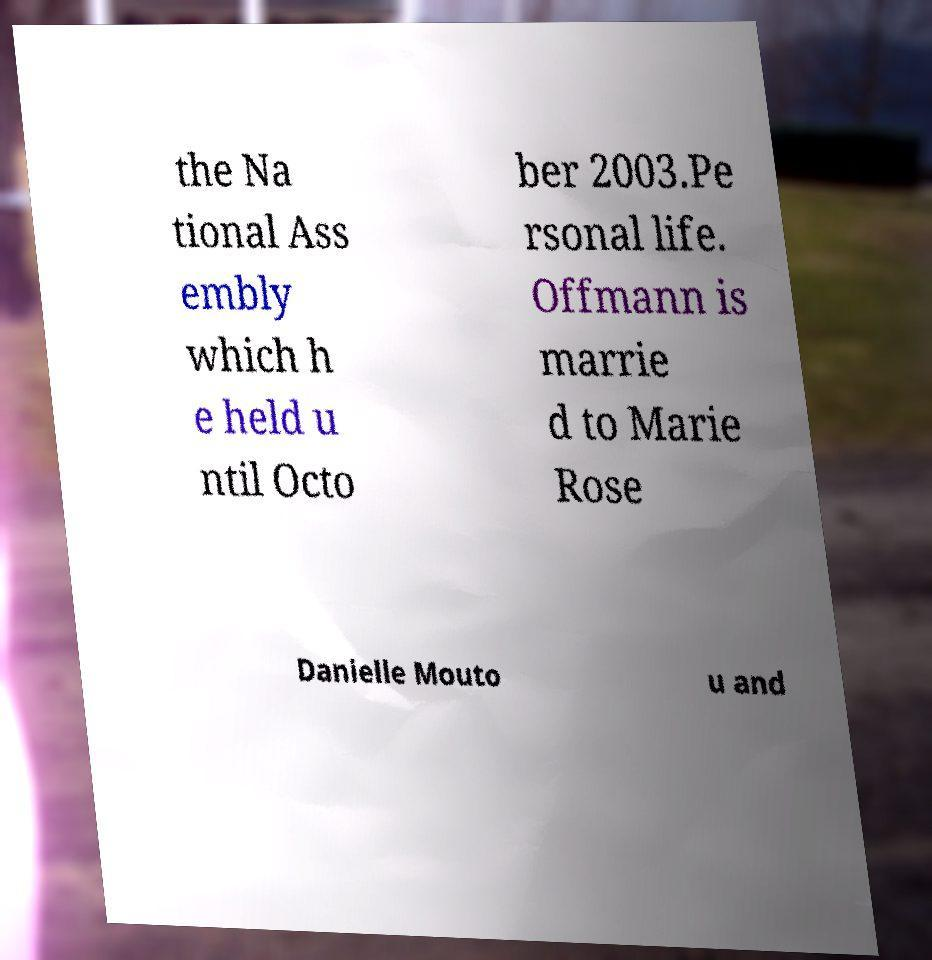There's text embedded in this image that I need extracted. Can you transcribe it verbatim? the Na tional Ass embly which h e held u ntil Octo ber 2003.Pe rsonal life. Offmann is marrie d to Marie Rose Danielle Mouto u and 